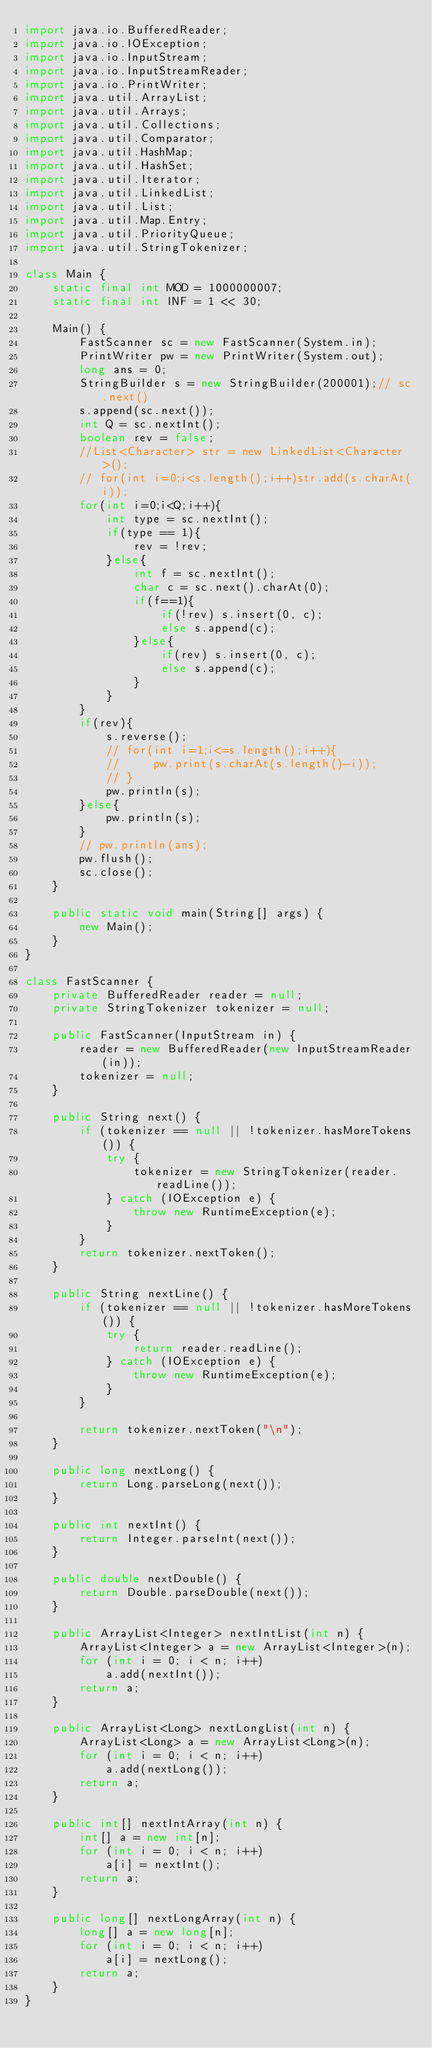<code> <loc_0><loc_0><loc_500><loc_500><_Java_>import java.io.BufferedReader;
import java.io.IOException;
import java.io.InputStream;
import java.io.InputStreamReader;
import java.io.PrintWriter;
import java.util.ArrayList;
import java.util.Arrays;
import java.util.Collections;
import java.util.Comparator;
import java.util.HashMap;
import java.util.HashSet;
import java.util.Iterator;
import java.util.LinkedList;
import java.util.List;
import java.util.Map.Entry;
import java.util.PriorityQueue;
import java.util.StringTokenizer;
 
class Main {
    static final int MOD = 1000000007;
    static final int INF = 1 << 30;
 
    Main() {
        FastScanner sc = new FastScanner(System.in);
        PrintWriter pw = new PrintWriter(System.out);
        long ans = 0;
        StringBuilder s = new StringBuilder(200001);// sc.next()
        s.append(sc.next());
      	int Q = sc.nextInt();
        boolean rev = false;
        //List<Character> str = new LinkedList<Character>();
        // for(int i=0;i<s.length();i++)str.add(s.charAt(i));
        for(int i=0;i<Q;i++){
            int type = sc.nextInt();
            if(type == 1){
                rev = !rev;
            }else{
                int f = sc.nextInt();
                char c = sc.next().charAt(0);
                if(f==1){
                    if(!rev) s.insert(0, c);
                    else s.append(c);
                }else{
                    if(rev) s.insert(0, c);
                    else s.append(c);
                }
            }
        }
        if(rev){
            s.reverse();
            // for(int i=1;i<=s.length();i++){
            //     pw.print(s.charAt(s.length()-i));
            // }
            pw.println(s);
        }else{
            pw.println(s);
        }
        // pw.println(ans);
        pw.flush();
        sc.close();
    }
 
    public static void main(String[] args) {
        new Main();
    }
}
 
class FastScanner {
    private BufferedReader reader = null;
    private StringTokenizer tokenizer = null;
 
    public FastScanner(InputStream in) {
        reader = new BufferedReader(new InputStreamReader(in));
        tokenizer = null;
    }
 
    public String next() {
        if (tokenizer == null || !tokenizer.hasMoreTokens()) {
            try {
                tokenizer = new StringTokenizer(reader.readLine());
            } catch (IOException e) {
                throw new RuntimeException(e);
            }
        }
        return tokenizer.nextToken();
    }
 
    public String nextLine() {
        if (tokenizer == null || !tokenizer.hasMoreTokens()) {
            try {
                return reader.readLine();
            } catch (IOException e) {
                throw new RuntimeException(e);
            }
        }
 
        return tokenizer.nextToken("\n");
    }
 
    public long nextLong() {
        return Long.parseLong(next());
    }
 
    public int nextInt() {
        return Integer.parseInt(next());
    }
 
    public double nextDouble() {
        return Double.parseDouble(next());
    }
 
    public ArrayList<Integer> nextIntList(int n) {
        ArrayList<Integer> a = new ArrayList<Integer>(n);
        for (int i = 0; i < n; i++)
            a.add(nextInt());
        return a;
    }
 
    public ArrayList<Long> nextLongList(int n) {
        ArrayList<Long> a = new ArrayList<Long>(n);
        for (int i = 0; i < n; i++)
            a.add(nextLong());
        return a;
    }
    
    public int[] nextIntArray(int n) {
        int[] a = new int[n];
        for (int i = 0; i < n; i++)
            a[i] = nextInt();
        return a;
    }
 
    public long[] nextLongArray(int n) {
        long[] a = new long[n];
        for (int i = 0; i < n; i++)
            a[i] = nextLong();
        return a;
    }
}
</code> 